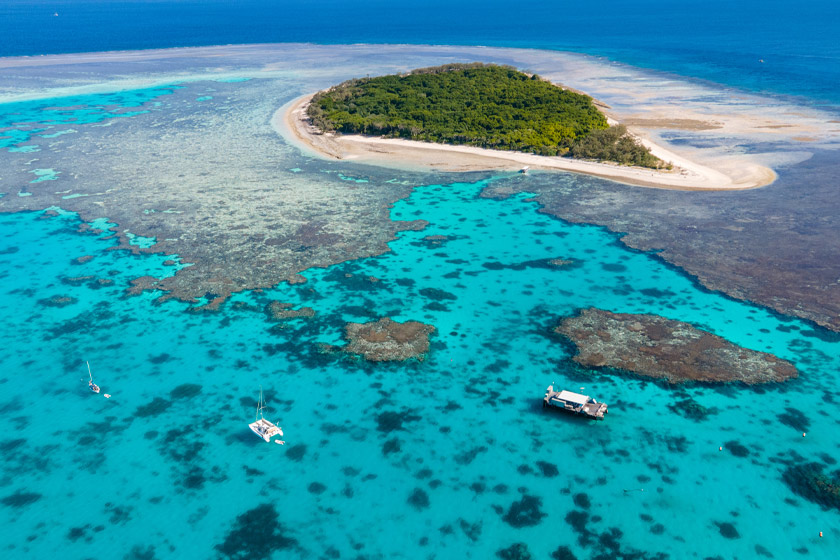What's the best time of day to take such a photograph? The best time to capture a photograph like this is during the mid-morning to early afternoon, when the sun is high in the sky. At this time, the sunlight penetrates the water most effectively, illuminating the vibrant colors of the coral reefs and the turquoise waters. The brightness enhances the contrast between the lush green of the island and the surrounding blue ocean, creating a beautifully crisp and vivid image. Additionally, during these hours, there is less likelihood of harsh shadows, ensuring the entire scene is well-lit and the details are clear and distinct. If you were to take a night dive here, what would you see? A night dive at the Great Barrier Reef offers a completely different yet equally mesmerizing experience. The underwater world transforms as nocturnal creatures emerge and bioluminescent organisms light up the dark waters with their ethereal glow. You would likely encounter nocturnal fish, such as squirrelfish and soldierfish, along with lobsters and crabs scuttling across the seabed. Moray eels might poke their heads out from hiding spots, and sometimes even larger predators like reef sharks and rays can be observed patrolling the reef. The coral polyps, which are usually retracted during the day, extend their tentacles to feed, creating a living, breathing tapestry that is breathtaking to behold under the ambient light of your dive torch. Can you create a poetic description of this image? Beneath the azure canvas where ocean kisses sky, 
Lies an emerald isle, swathed in nature's green sigh. 
The sea, a mosaic of turquoise and deep blue,
Cradles corals that weave dreams in hues old and new.
Boats dance on liquid glass, seeking the reef's embrace,
While sunlight scatters diamonds, illuminating this place.
A paradise so splendid, where life and colors spin,
The Great Barrier Reef, nature's flawless, vibrant hymn. 